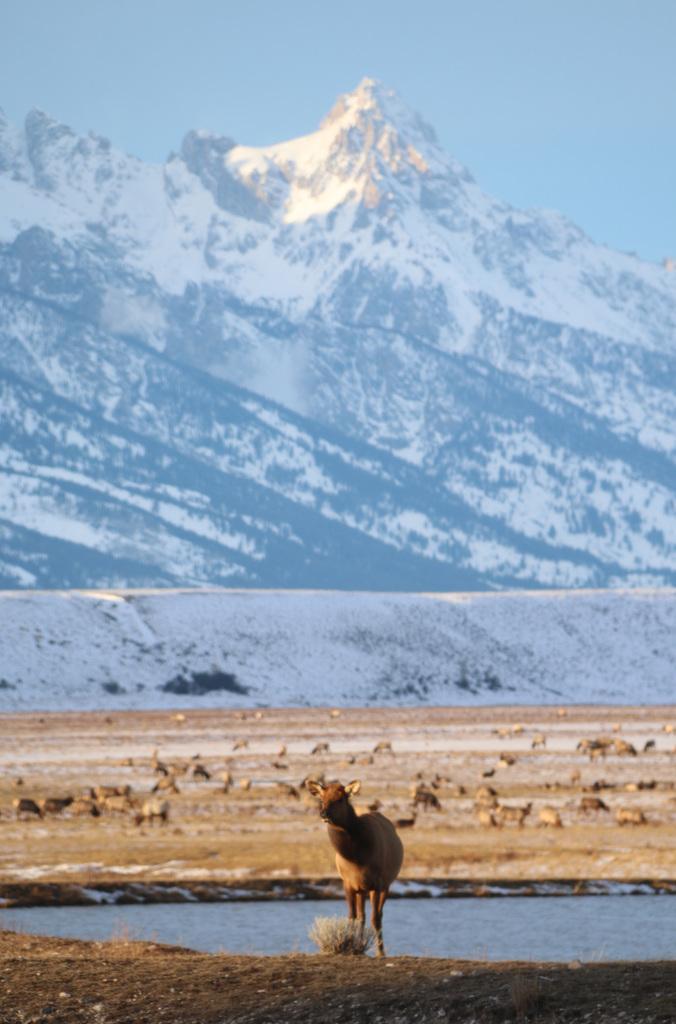In one or two sentences, can you explain what this image depicts? In this image, we can see animals on the ground and there is water. In the background, there are mountains. 